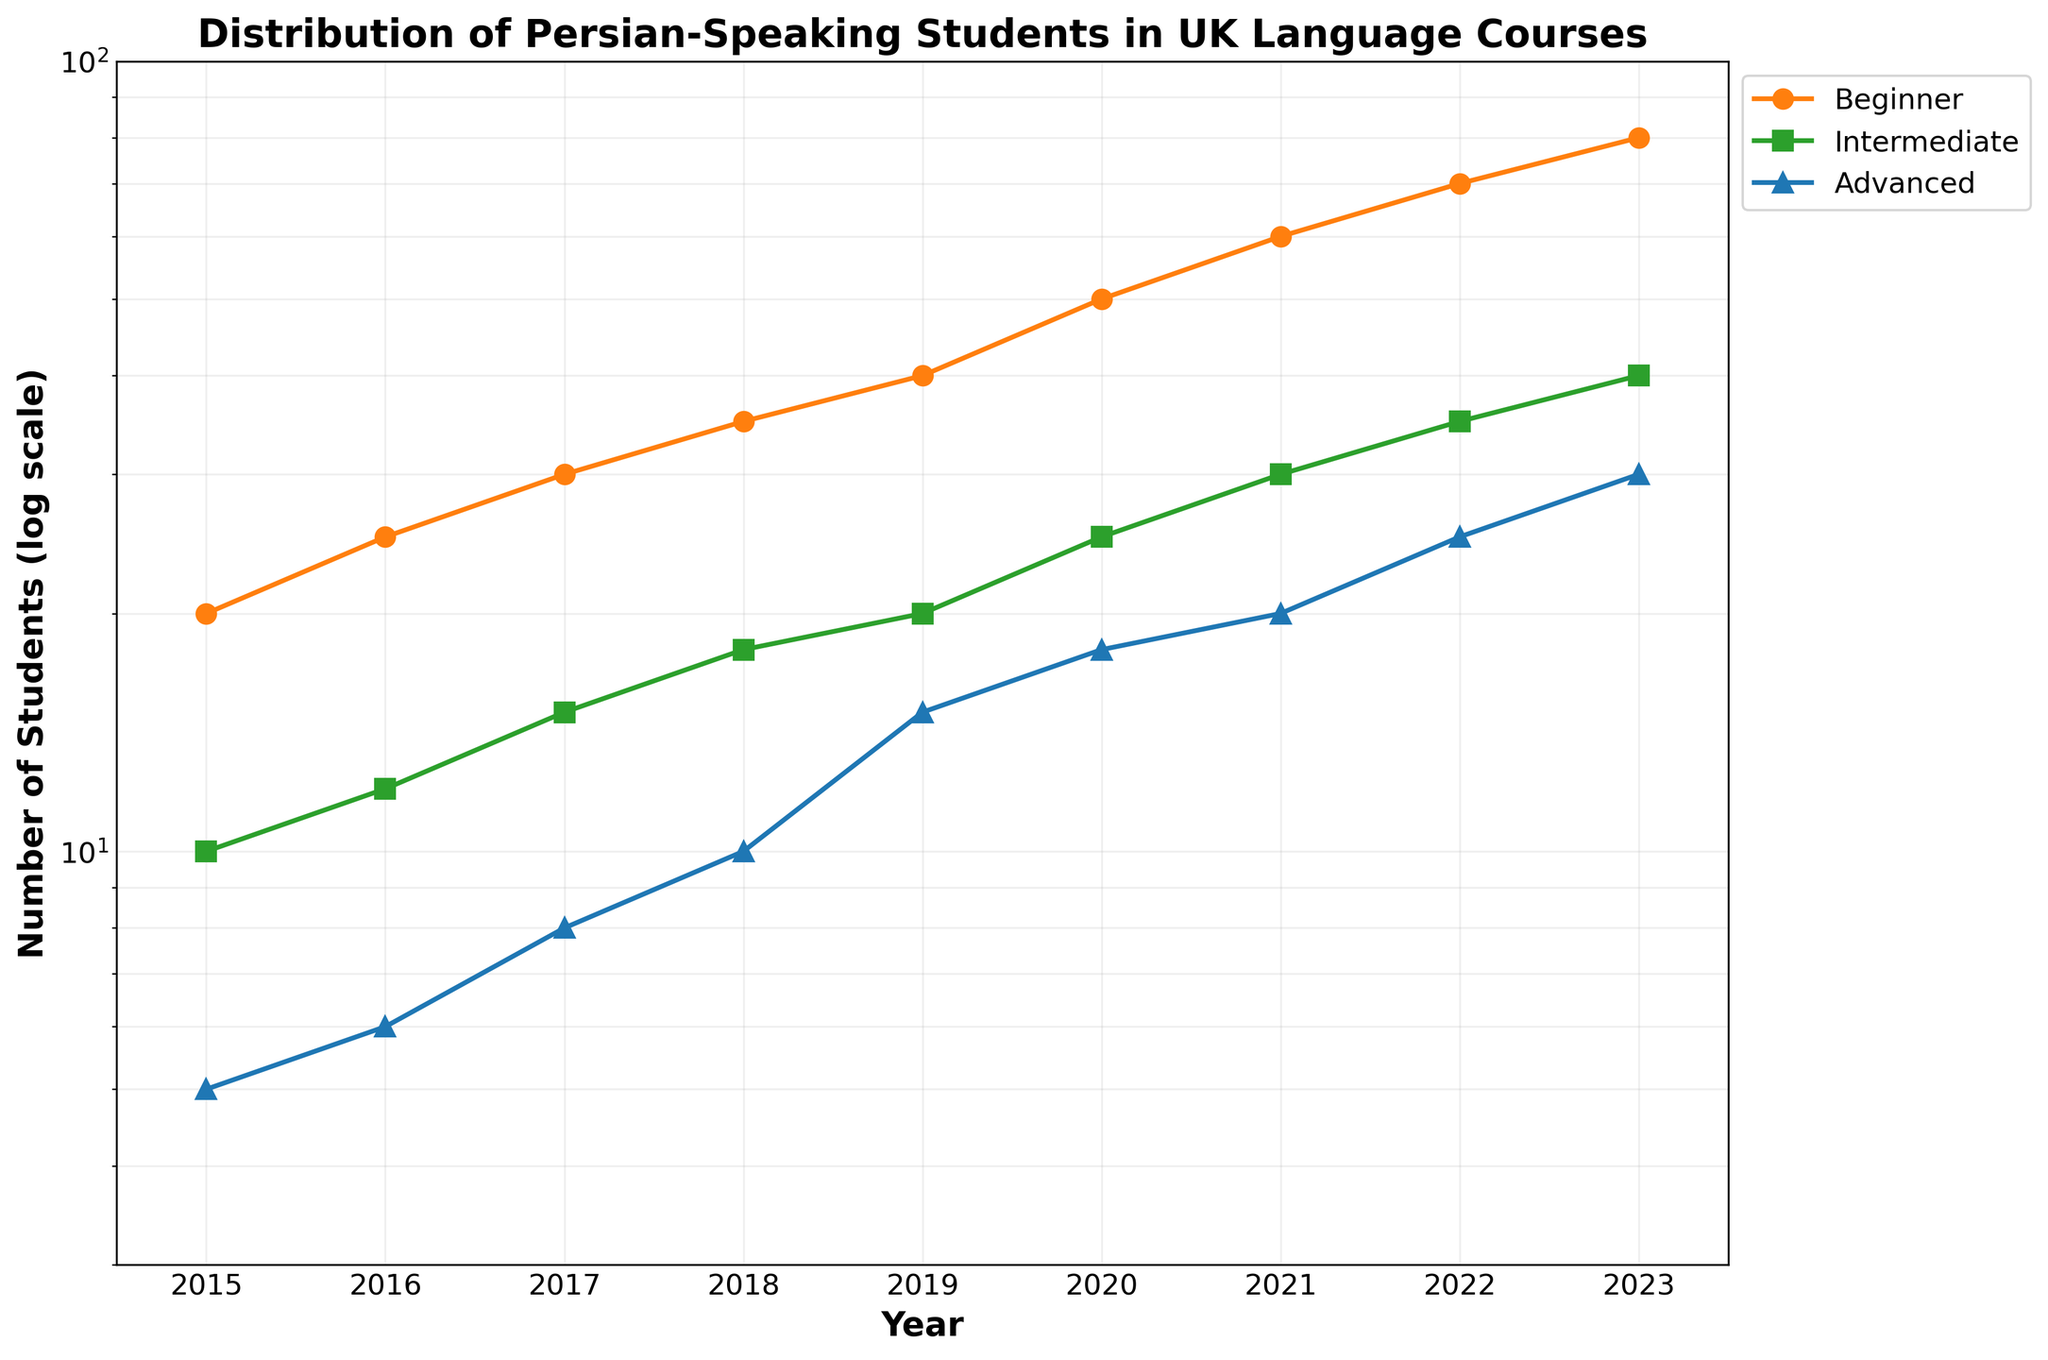what is the title of the figure? The title of the figure is usually found at the top. In this case, it is clearly indicated in a bold font.
Answer: Distribution of Persian-Speaking Students in UK Language Courses What is the pattern of the Beginner level students over the years shown? Beginner level students start at 20 in 2015 and show a consistent increase each year, ending at 80 in 2023. This is shown by the upward trend of the orange line with circle markers.
Answer: Increasing How many students were enrolled at the Advanced level in the year 2021? Look at the blue line with triangle markers for the year 2021 on the x-axis. The number corresponding to it on the y-axis is 20.
Answer: 20 What is the difference between the number of Beginner and Advanced students in 2019? Look at the 2019 data points for both Beginner and Advanced levels. The Beginner level has 40 students, and the Advanced level has 15 students. The difference is 40 - 15.
Answer: 25 Which proficiency level saw the highest proportional increase from 2015 to 2023? Compare the initial and final values of all three proficiency levels. Beginner increased from 20 to 80, Intermediate from 10 to 40, and Advanced from 5 to 30. Calculate the proportional increase as (final-initial)/initial. Beginner: (80-20)/20 = 3, Intermediate: (40-10)/10 = 3, Advanced: (30-5)/5 = 5.
Answer: Advanced What is the combined number of students across all levels in 2020? Add the data points for all three levels in 2020. Beginner has 50, Intermediate has 25, and Advanced has 18. The sum is 50 + 25 + 18.
Answer: 93 Which years had the same number of Intermediate and Advanced level students? The Intermediate and Advanced levels can be checked year by year. On comparing, no years have the same number of Intermediate and Advanced students.
Answer: None What is the general trend displayed in the plot for Persian language proficiency levels in the UK? Observe the lines for all proficiency levels. All show a generally increasing trend over the years, indicating more students are enrolling in language courses each year.
Answer: Increasing For which year and proficiency level combination has the lowest log scale value observed? The lowest value will be insignificantly highest value when converted into log scale but comparing the actual value. Compare values from all years and proficiency levels; the lowest one is 5 for Advanced in 2015.
Answer: Advanced in 2015 What's the doubling year for Beginner students' enrollment from 2015 to 2023? Examine the year when the Beginner level enrollment was twice its number in 2015. In 2015, it was 20. So, find the first year where it is 40, which is 2019.
Answer: 2019 